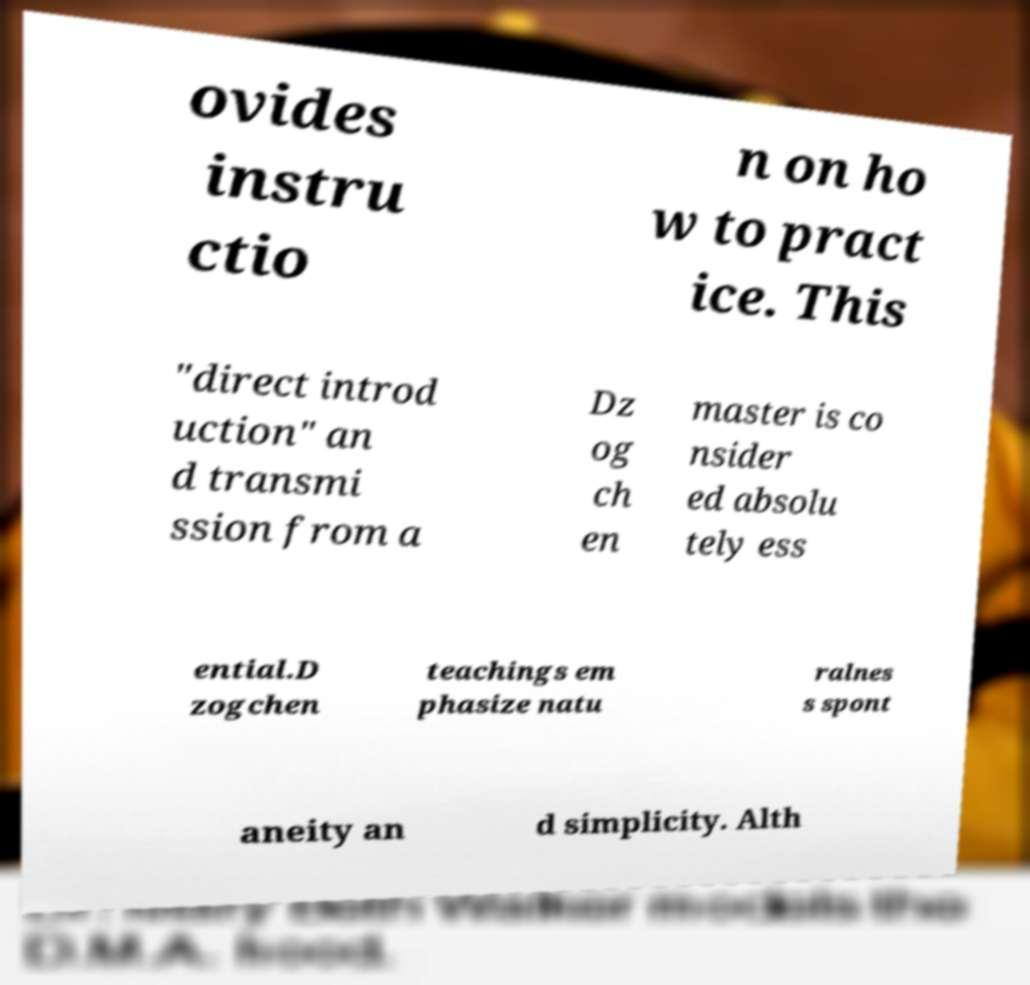I need the written content from this picture converted into text. Can you do that? ovides instru ctio n on ho w to pract ice. This "direct introd uction" an d transmi ssion from a Dz og ch en master is co nsider ed absolu tely ess ential.D zogchen teachings em phasize natu ralnes s spont aneity an d simplicity. Alth 